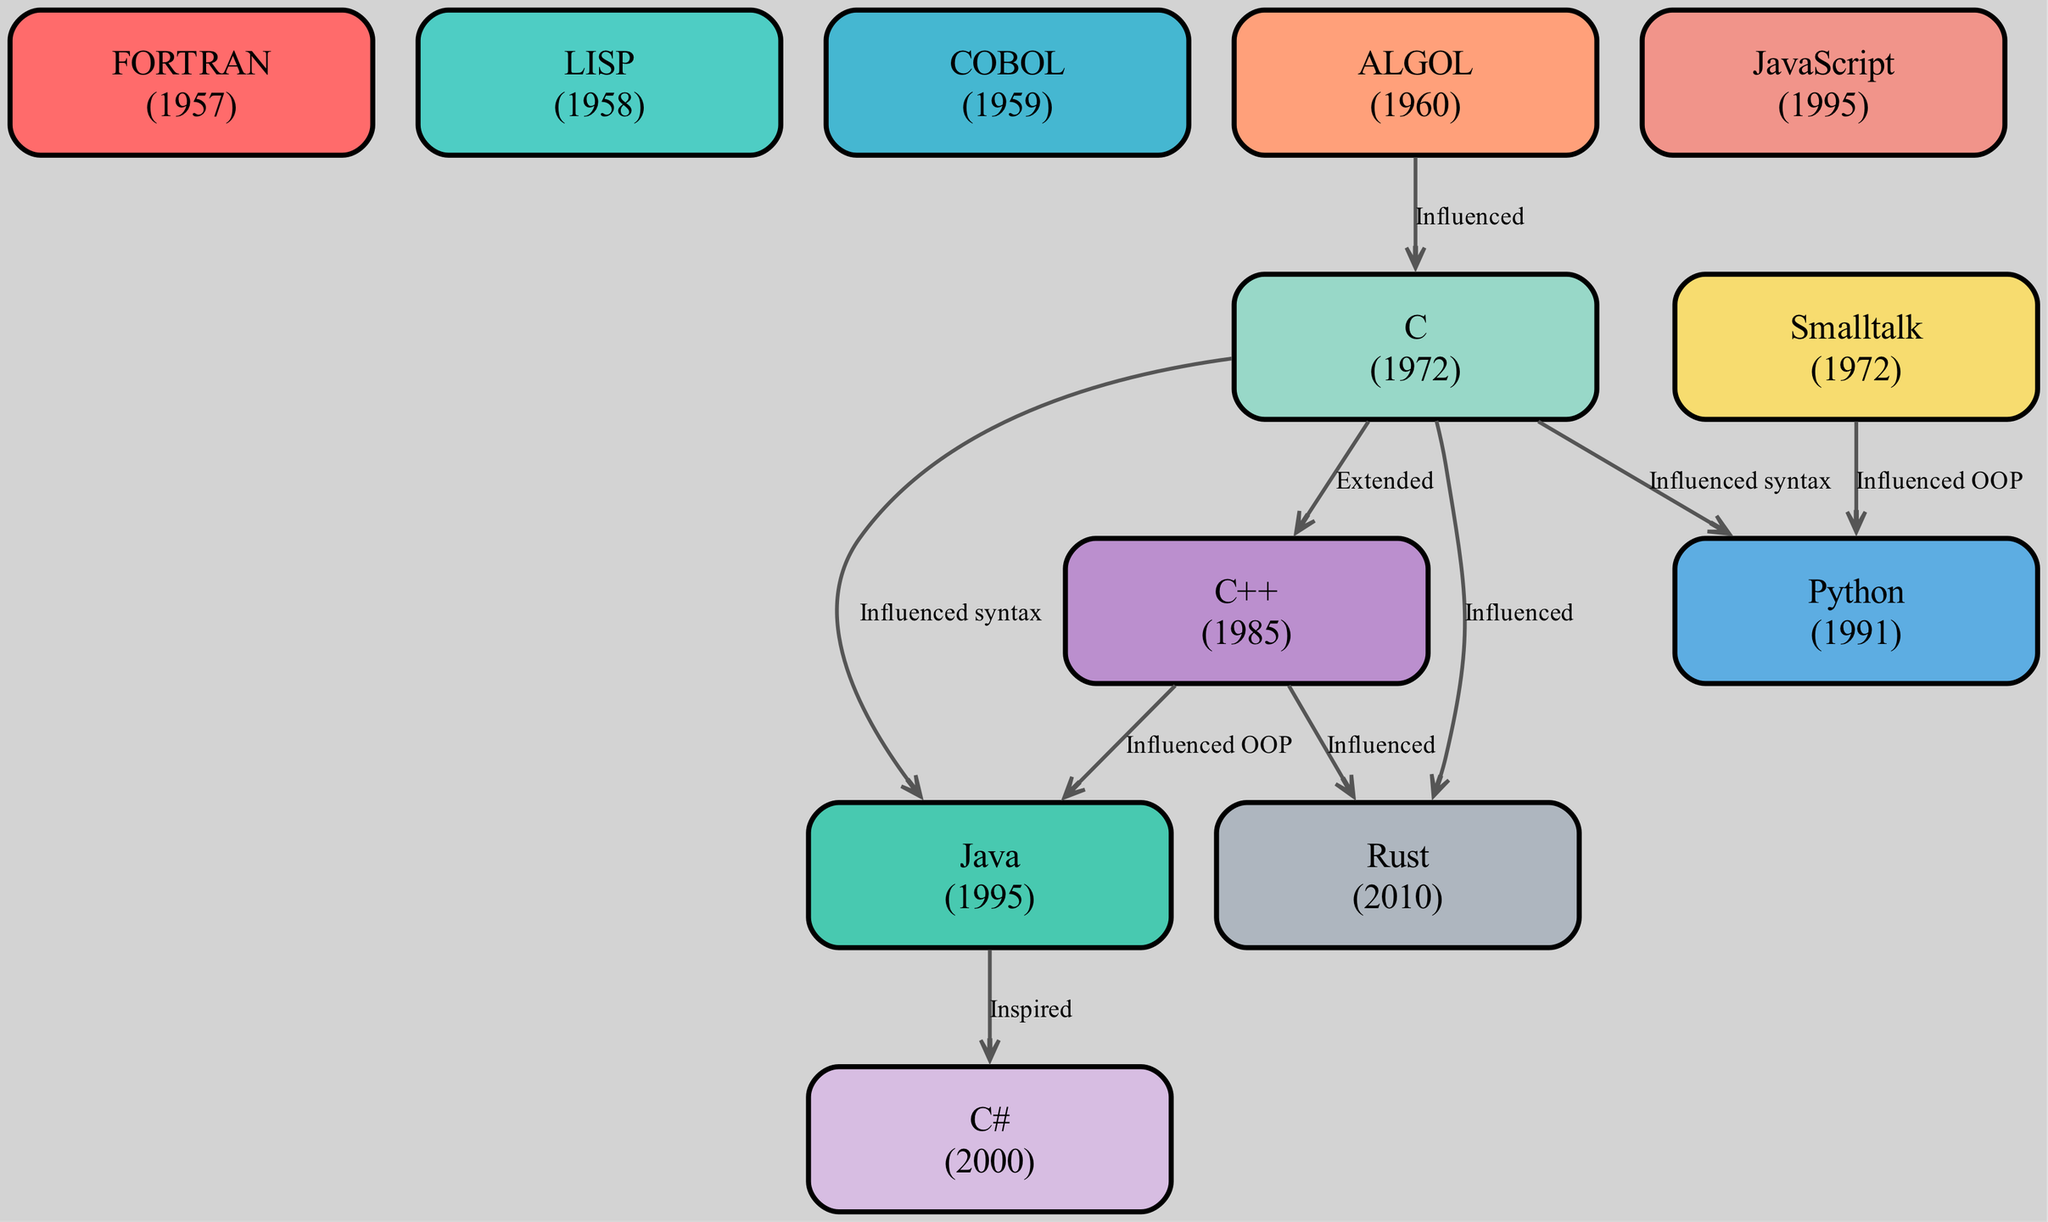What year was FORTRAN released? FORTRAN is listed as one of the nodes in the diagram with the year mentioned next to its name. The year for FORTRAN is 1957.
Answer: 1957 How many programming languages are displayed in the diagram? To find the total number of programming languages, count the number of nodes present in the diagram. There are 12 distinct programming languages in the list.
Answer: 12 Which language did ALGOL influence? By examining the edges connected to ALGOL, it shows that it has an edge pointing to C with the label "Influenced." Thus, ALGOL specifically influenced C.
Answer: C What is a common characteristic of languages that influence Rust? Both C and C++ have directed edges pointing towards Rust labeled "Influenced," indicating that Rust is influenced by both of these languages, suggesting a combination of their characteristics in Rust’s design, focusing on systems programming.
Answer: C and C++ What programming language is described as an "OOP extension of C"? The description of the language "C++" in the nodes indicates that it is an "OOP extension of C." Therefore, C++ is the answer to this question.
Answer: C++ Which programming language is described as "Web scripting"? Looking through the nodes, the language listed with the description "Web scripting" is JavaScript.
Answer: JavaScript What is the relationship between Smalltalk and Python? Examining the edges in the diagram shows that Smalltalk has an influence on Python, with the edge labeled "Influenced OOP." This indicates a direct connection where Smalltalk influenced the object-oriented aspect of Python.
Answer: Influenced OOP What year did JavaScript emerge? The node for JavaScript lists the year next to the language's name, which indicates that JavaScript was released in 1995.
Answer: 1995 List the programming language that was inspired by Java. Java has a directed edge pointing to C# with the label "Inspired," indicating that C# is the programming language inspired by Java.
Answer: C# 